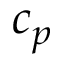<formula> <loc_0><loc_0><loc_500><loc_500>c _ { p }</formula> 